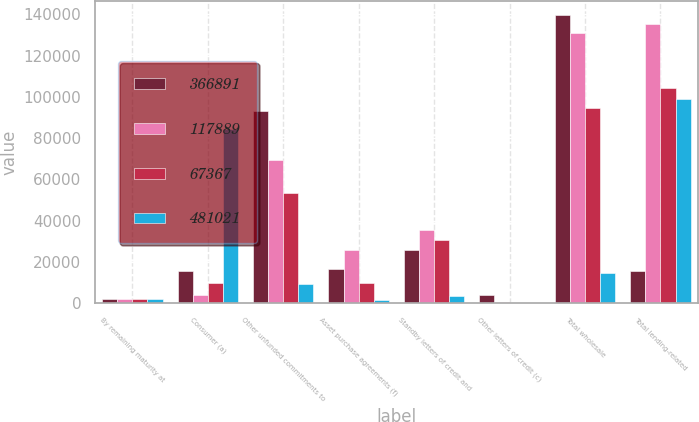Convert chart to OTSL. <chart><loc_0><loc_0><loc_500><loc_500><stacked_bar_chart><ecel><fcel>By remaining maturity at<fcel>Consumer (a)<fcel>Other unfunded commitments to<fcel>Asset purchase agreements (f)<fcel>Standby letters of credit and<fcel>Other letters of credit (c)<fcel>Total wholesale<fcel>Total lending-related<nl><fcel>366891<fcel>2008<fcel>15589<fcel>93307<fcel>16467<fcel>25998<fcel>3889<fcel>139661<fcel>15589<nl><fcel>117889<fcel>2008<fcel>4098<fcel>69479<fcel>25574<fcel>35288<fcel>718<fcel>131059<fcel>135157<nl><fcel>67367<fcel>2008<fcel>9916<fcel>53567<fcel>9983<fcel>30650<fcel>240<fcel>94440<fcel>104356<nl><fcel>481021<fcel>2008<fcel>84515<fcel>9510<fcel>1705<fcel>3416<fcel>80<fcel>14711<fcel>99226<nl></chart> 